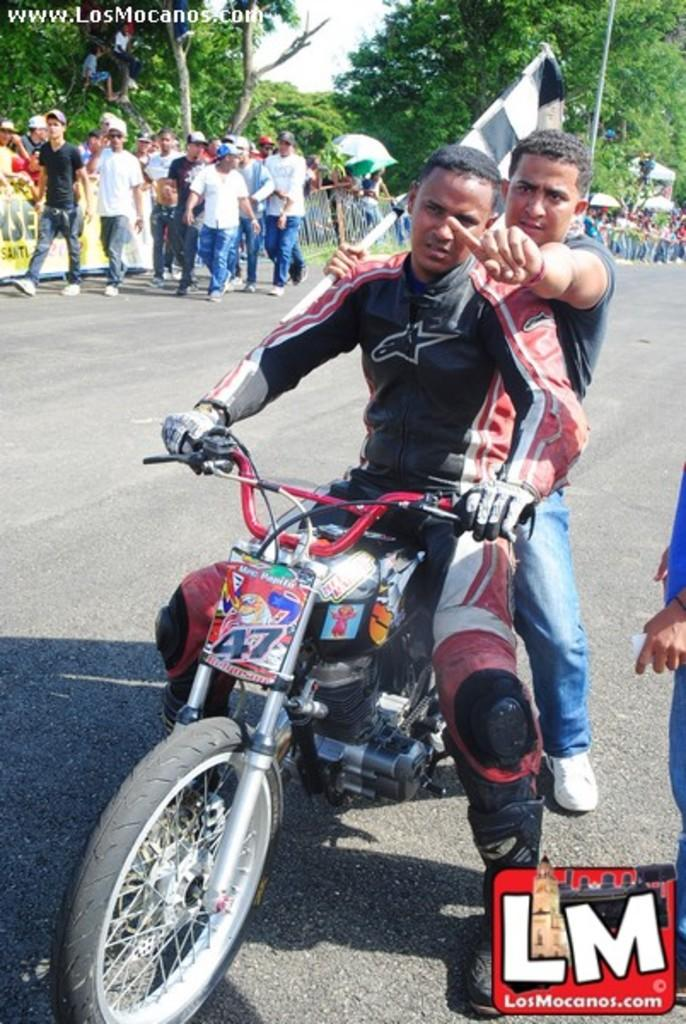What are the two persons doing in the image? The two persons are riding a motorcycle in the image. Where is the motorcycle located? The motorcycle is on the road in the image. What else can be seen on the road in the image? There are people walking on the road in the image. What can be seen in the background of the image? There are trees visible at the top of the image. What is the topic of the discussion between the two persons riding the motorcycle? There is no discussion taking place between the two persons riding the motorcycle in the image. 